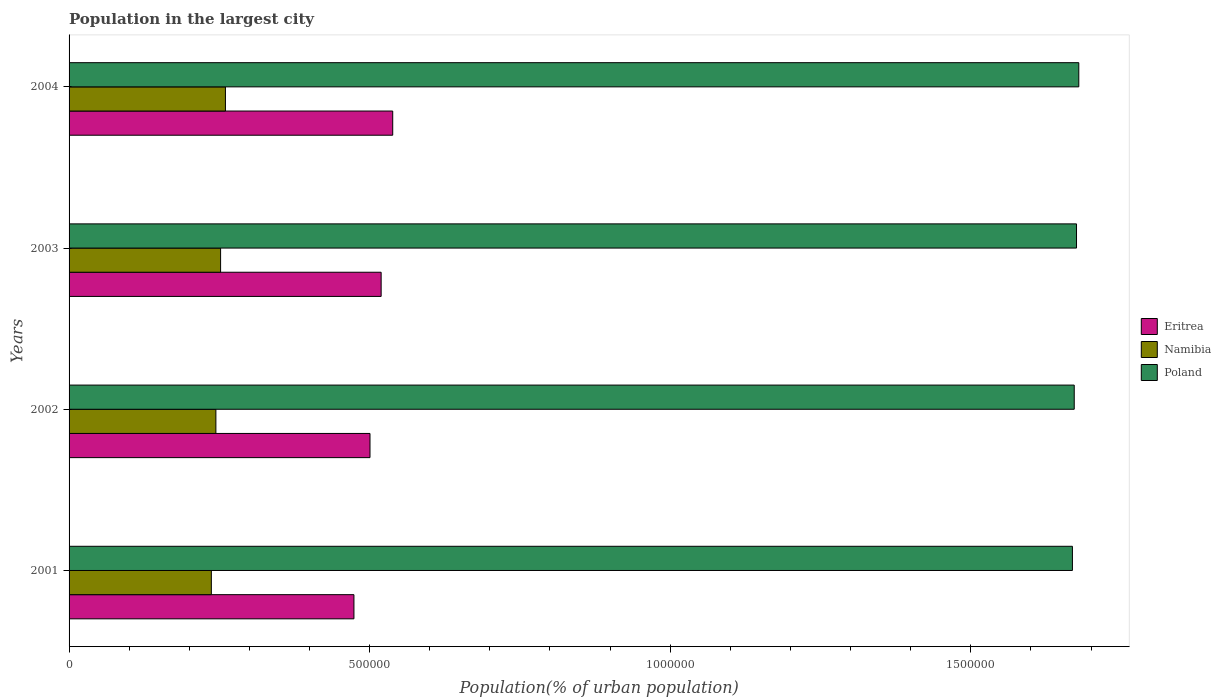How many different coloured bars are there?
Offer a very short reply. 3. Are the number of bars per tick equal to the number of legend labels?
Make the answer very short. Yes. Are the number of bars on each tick of the Y-axis equal?
Keep it short and to the point. Yes. How many bars are there on the 3rd tick from the top?
Provide a succinct answer. 3. What is the label of the 4th group of bars from the top?
Offer a terse response. 2001. In how many cases, is the number of bars for a given year not equal to the number of legend labels?
Offer a very short reply. 0. What is the population in the largest city in Poland in 2001?
Keep it short and to the point. 1.67e+06. Across all years, what is the maximum population in the largest city in Eritrea?
Your answer should be very brief. 5.38e+05. Across all years, what is the minimum population in the largest city in Namibia?
Provide a succinct answer. 2.37e+05. In which year was the population in the largest city in Eritrea minimum?
Provide a short and direct response. 2001. What is the total population in the largest city in Namibia in the graph?
Provide a succinct answer. 9.93e+05. What is the difference between the population in the largest city in Eritrea in 2001 and that in 2002?
Keep it short and to the point. -2.67e+04. What is the difference between the population in the largest city in Eritrea in 2001 and the population in the largest city in Namibia in 2002?
Your response must be concise. 2.30e+05. What is the average population in the largest city in Poland per year?
Make the answer very short. 1.67e+06. In the year 2002, what is the difference between the population in the largest city in Poland and population in the largest city in Namibia?
Give a very brief answer. 1.43e+06. What is the ratio of the population in the largest city in Poland in 2003 to that in 2004?
Offer a terse response. 1. Is the population in the largest city in Poland in 2002 less than that in 2003?
Keep it short and to the point. Yes. Is the difference between the population in the largest city in Poland in 2002 and 2003 greater than the difference between the population in the largest city in Namibia in 2002 and 2003?
Offer a very short reply. Yes. What is the difference between the highest and the second highest population in the largest city in Eritrea?
Ensure brevity in your answer.  1.93e+04. What is the difference between the highest and the lowest population in the largest city in Namibia?
Your answer should be compact. 2.35e+04. What does the 1st bar from the top in 2004 represents?
Give a very brief answer. Poland. What does the 3rd bar from the bottom in 2003 represents?
Your response must be concise. Poland. Is it the case that in every year, the sum of the population in the largest city in Poland and population in the largest city in Eritrea is greater than the population in the largest city in Namibia?
Your answer should be very brief. Yes. How many bars are there?
Ensure brevity in your answer.  12. How many years are there in the graph?
Your answer should be compact. 4. What is the difference between two consecutive major ticks on the X-axis?
Your answer should be compact. 5.00e+05. Does the graph contain grids?
Keep it short and to the point. No. Where does the legend appear in the graph?
Ensure brevity in your answer.  Center right. How many legend labels are there?
Ensure brevity in your answer.  3. How are the legend labels stacked?
Offer a very short reply. Vertical. What is the title of the graph?
Make the answer very short. Population in the largest city. What is the label or title of the X-axis?
Offer a terse response. Population(% of urban population). What is the Population(% of urban population) in Eritrea in 2001?
Offer a very short reply. 4.74e+05. What is the Population(% of urban population) in Namibia in 2001?
Your answer should be very brief. 2.37e+05. What is the Population(% of urban population) of Poland in 2001?
Your answer should be very brief. 1.67e+06. What is the Population(% of urban population) of Eritrea in 2002?
Provide a short and direct response. 5.01e+05. What is the Population(% of urban population) in Namibia in 2002?
Make the answer very short. 2.44e+05. What is the Population(% of urban population) in Poland in 2002?
Make the answer very short. 1.67e+06. What is the Population(% of urban population) of Eritrea in 2003?
Your answer should be very brief. 5.19e+05. What is the Population(% of urban population) in Namibia in 2003?
Keep it short and to the point. 2.52e+05. What is the Population(% of urban population) of Poland in 2003?
Provide a short and direct response. 1.68e+06. What is the Population(% of urban population) of Eritrea in 2004?
Give a very brief answer. 5.38e+05. What is the Population(% of urban population) in Namibia in 2004?
Offer a very short reply. 2.60e+05. What is the Population(% of urban population) of Poland in 2004?
Offer a very short reply. 1.68e+06. Across all years, what is the maximum Population(% of urban population) in Eritrea?
Offer a terse response. 5.38e+05. Across all years, what is the maximum Population(% of urban population) of Namibia?
Give a very brief answer. 2.60e+05. Across all years, what is the maximum Population(% of urban population) of Poland?
Offer a very short reply. 1.68e+06. Across all years, what is the minimum Population(% of urban population) in Eritrea?
Offer a very short reply. 4.74e+05. Across all years, what is the minimum Population(% of urban population) of Namibia?
Your response must be concise. 2.37e+05. Across all years, what is the minimum Population(% of urban population) of Poland?
Give a very brief answer. 1.67e+06. What is the total Population(% of urban population) in Eritrea in the graph?
Your answer should be compact. 2.03e+06. What is the total Population(% of urban population) in Namibia in the graph?
Keep it short and to the point. 9.93e+05. What is the total Population(% of urban population) of Poland in the graph?
Offer a very short reply. 6.70e+06. What is the difference between the Population(% of urban population) in Eritrea in 2001 and that in 2002?
Your answer should be compact. -2.67e+04. What is the difference between the Population(% of urban population) in Namibia in 2001 and that in 2002?
Your answer should be compact. -7568. What is the difference between the Population(% of urban population) of Poland in 2001 and that in 2002?
Your response must be concise. -3016. What is the difference between the Population(% of urban population) in Eritrea in 2001 and that in 2003?
Offer a terse response. -4.53e+04. What is the difference between the Population(% of urban population) of Namibia in 2001 and that in 2003?
Offer a very short reply. -1.54e+04. What is the difference between the Population(% of urban population) of Poland in 2001 and that in 2003?
Your answer should be compact. -6809. What is the difference between the Population(% of urban population) in Eritrea in 2001 and that in 2004?
Your response must be concise. -6.45e+04. What is the difference between the Population(% of urban population) in Namibia in 2001 and that in 2004?
Provide a succinct answer. -2.35e+04. What is the difference between the Population(% of urban population) of Poland in 2001 and that in 2004?
Your answer should be very brief. -1.06e+04. What is the difference between the Population(% of urban population) of Eritrea in 2002 and that in 2003?
Your answer should be very brief. -1.85e+04. What is the difference between the Population(% of urban population) of Namibia in 2002 and that in 2003?
Offer a very short reply. -7811. What is the difference between the Population(% of urban population) in Poland in 2002 and that in 2003?
Make the answer very short. -3793. What is the difference between the Population(% of urban population) in Eritrea in 2002 and that in 2004?
Ensure brevity in your answer.  -3.78e+04. What is the difference between the Population(% of urban population) of Namibia in 2002 and that in 2004?
Make the answer very short. -1.59e+04. What is the difference between the Population(% of urban population) of Poland in 2002 and that in 2004?
Your response must be concise. -7599. What is the difference between the Population(% of urban population) of Eritrea in 2003 and that in 2004?
Your answer should be very brief. -1.93e+04. What is the difference between the Population(% of urban population) in Namibia in 2003 and that in 2004?
Offer a terse response. -8072. What is the difference between the Population(% of urban population) of Poland in 2003 and that in 2004?
Provide a short and direct response. -3806. What is the difference between the Population(% of urban population) in Eritrea in 2001 and the Population(% of urban population) in Namibia in 2002?
Give a very brief answer. 2.30e+05. What is the difference between the Population(% of urban population) in Eritrea in 2001 and the Population(% of urban population) in Poland in 2002?
Ensure brevity in your answer.  -1.20e+06. What is the difference between the Population(% of urban population) of Namibia in 2001 and the Population(% of urban population) of Poland in 2002?
Your answer should be very brief. -1.44e+06. What is the difference between the Population(% of urban population) of Eritrea in 2001 and the Population(% of urban population) of Namibia in 2003?
Offer a terse response. 2.22e+05. What is the difference between the Population(% of urban population) of Eritrea in 2001 and the Population(% of urban population) of Poland in 2003?
Provide a short and direct response. -1.20e+06. What is the difference between the Population(% of urban population) in Namibia in 2001 and the Population(% of urban population) in Poland in 2003?
Provide a short and direct response. -1.44e+06. What is the difference between the Population(% of urban population) in Eritrea in 2001 and the Population(% of urban population) in Namibia in 2004?
Your answer should be very brief. 2.14e+05. What is the difference between the Population(% of urban population) in Eritrea in 2001 and the Population(% of urban population) in Poland in 2004?
Keep it short and to the point. -1.21e+06. What is the difference between the Population(% of urban population) in Namibia in 2001 and the Population(% of urban population) in Poland in 2004?
Ensure brevity in your answer.  -1.44e+06. What is the difference between the Population(% of urban population) in Eritrea in 2002 and the Population(% of urban population) in Namibia in 2003?
Keep it short and to the point. 2.49e+05. What is the difference between the Population(% of urban population) of Eritrea in 2002 and the Population(% of urban population) of Poland in 2003?
Provide a short and direct response. -1.18e+06. What is the difference between the Population(% of urban population) in Namibia in 2002 and the Population(% of urban population) in Poland in 2003?
Your answer should be compact. -1.43e+06. What is the difference between the Population(% of urban population) of Eritrea in 2002 and the Population(% of urban population) of Namibia in 2004?
Provide a succinct answer. 2.40e+05. What is the difference between the Population(% of urban population) in Eritrea in 2002 and the Population(% of urban population) in Poland in 2004?
Ensure brevity in your answer.  -1.18e+06. What is the difference between the Population(% of urban population) in Namibia in 2002 and the Population(% of urban population) in Poland in 2004?
Offer a terse response. -1.44e+06. What is the difference between the Population(% of urban population) in Eritrea in 2003 and the Population(% of urban population) in Namibia in 2004?
Provide a succinct answer. 2.59e+05. What is the difference between the Population(% of urban population) of Eritrea in 2003 and the Population(% of urban population) of Poland in 2004?
Your answer should be very brief. -1.16e+06. What is the difference between the Population(% of urban population) in Namibia in 2003 and the Population(% of urban population) in Poland in 2004?
Your answer should be compact. -1.43e+06. What is the average Population(% of urban population) in Eritrea per year?
Make the answer very short. 5.08e+05. What is the average Population(% of urban population) of Namibia per year?
Provide a short and direct response. 2.48e+05. What is the average Population(% of urban population) in Poland per year?
Provide a short and direct response. 1.67e+06. In the year 2001, what is the difference between the Population(% of urban population) in Eritrea and Population(% of urban population) in Namibia?
Offer a very short reply. 2.37e+05. In the year 2001, what is the difference between the Population(% of urban population) in Eritrea and Population(% of urban population) in Poland?
Provide a short and direct response. -1.20e+06. In the year 2001, what is the difference between the Population(% of urban population) of Namibia and Population(% of urban population) of Poland?
Your response must be concise. -1.43e+06. In the year 2002, what is the difference between the Population(% of urban population) in Eritrea and Population(% of urban population) in Namibia?
Give a very brief answer. 2.56e+05. In the year 2002, what is the difference between the Population(% of urban population) of Eritrea and Population(% of urban population) of Poland?
Offer a terse response. -1.17e+06. In the year 2002, what is the difference between the Population(% of urban population) of Namibia and Population(% of urban population) of Poland?
Offer a terse response. -1.43e+06. In the year 2003, what is the difference between the Population(% of urban population) of Eritrea and Population(% of urban population) of Namibia?
Keep it short and to the point. 2.67e+05. In the year 2003, what is the difference between the Population(% of urban population) in Eritrea and Population(% of urban population) in Poland?
Provide a short and direct response. -1.16e+06. In the year 2003, what is the difference between the Population(% of urban population) of Namibia and Population(% of urban population) of Poland?
Provide a succinct answer. -1.42e+06. In the year 2004, what is the difference between the Population(% of urban population) in Eritrea and Population(% of urban population) in Namibia?
Keep it short and to the point. 2.78e+05. In the year 2004, what is the difference between the Population(% of urban population) of Eritrea and Population(% of urban population) of Poland?
Ensure brevity in your answer.  -1.14e+06. In the year 2004, what is the difference between the Population(% of urban population) in Namibia and Population(% of urban population) in Poland?
Your response must be concise. -1.42e+06. What is the ratio of the Population(% of urban population) of Eritrea in 2001 to that in 2002?
Your answer should be compact. 0.95. What is the ratio of the Population(% of urban population) of Eritrea in 2001 to that in 2003?
Offer a very short reply. 0.91. What is the ratio of the Population(% of urban population) of Namibia in 2001 to that in 2003?
Provide a succinct answer. 0.94. What is the ratio of the Population(% of urban population) in Poland in 2001 to that in 2003?
Offer a very short reply. 1. What is the ratio of the Population(% of urban population) in Eritrea in 2001 to that in 2004?
Offer a very short reply. 0.88. What is the ratio of the Population(% of urban population) of Namibia in 2001 to that in 2004?
Your response must be concise. 0.91. What is the ratio of the Population(% of urban population) of Namibia in 2002 to that in 2003?
Offer a very short reply. 0.97. What is the ratio of the Population(% of urban population) of Poland in 2002 to that in 2003?
Make the answer very short. 1. What is the ratio of the Population(% of urban population) of Eritrea in 2002 to that in 2004?
Offer a very short reply. 0.93. What is the ratio of the Population(% of urban population) in Namibia in 2002 to that in 2004?
Your answer should be very brief. 0.94. What is the ratio of the Population(% of urban population) of Eritrea in 2003 to that in 2004?
Ensure brevity in your answer.  0.96. What is the difference between the highest and the second highest Population(% of urban population) in Eritrea?
Ensure brevity in your answer.  1.93e+04. What is the difference between the highest and the second highest Population(% of urban population) of Namibia?
Your answer should be compact. 8072. What is the difference between the highest and the second highest Population(% of urban population) of Poland?
Ensure brevity in your answer.  3806. What is the difference between the highest and the lowest Population(% of urban population) of Eritrea?
Give a very brief answer. 6.45e+04. What is the difference between the highest and the lowest Population(% of urban population) of Namibia?
Ensure brevity in your answer.  2.35e+04. What is the difference between the highest and the lowest Population(% of urban population) in Poland?
Your response must be concise. 1.06e+04. 